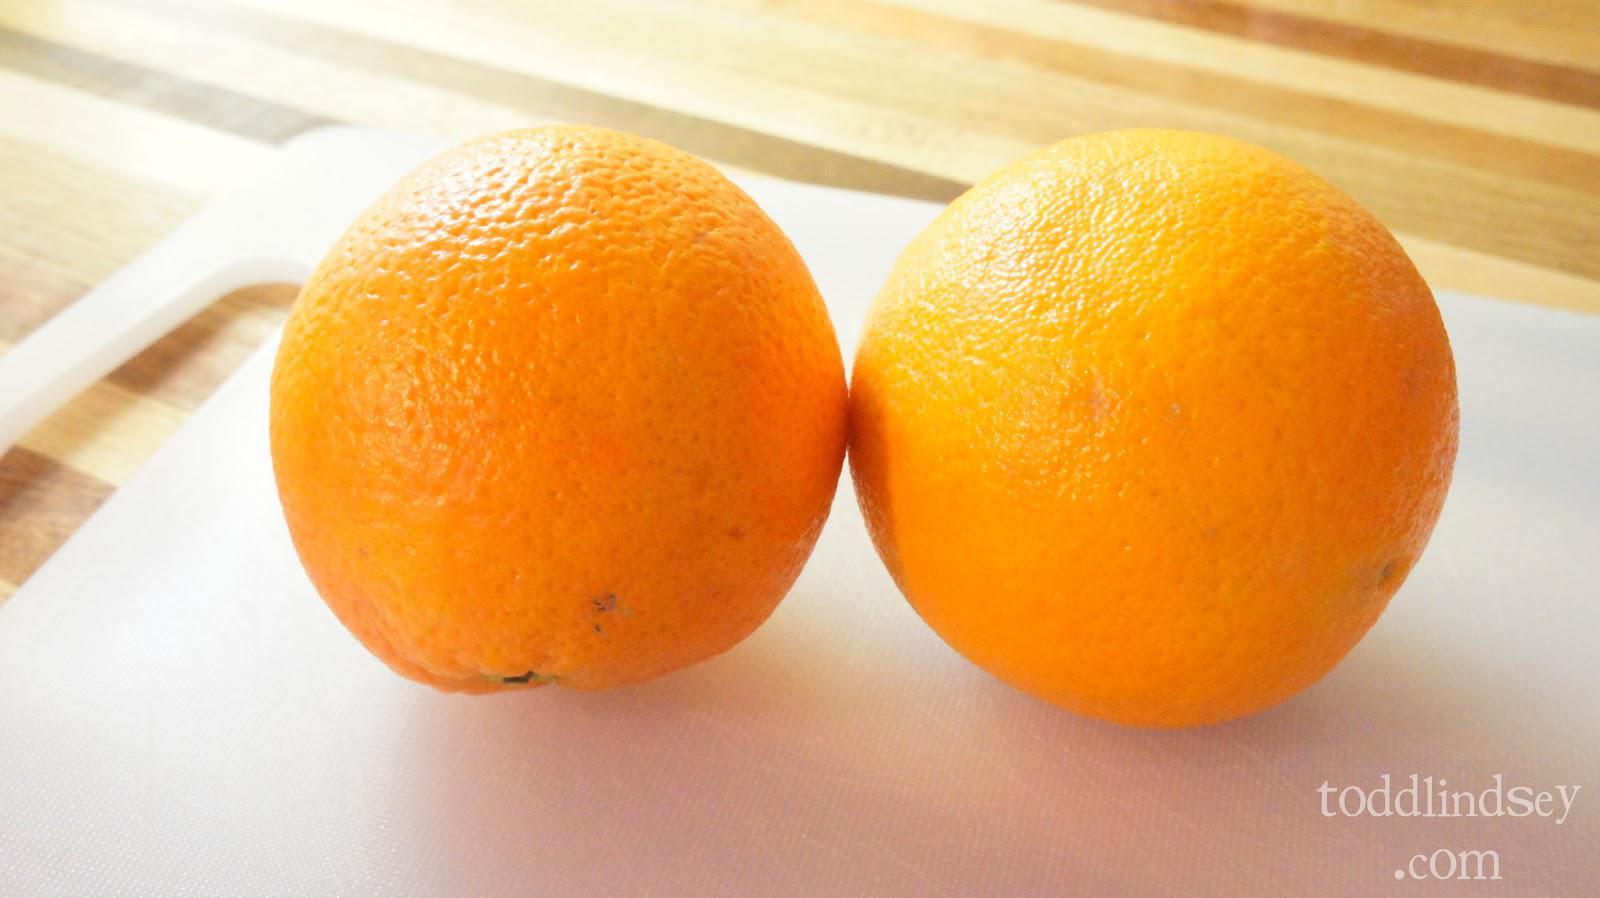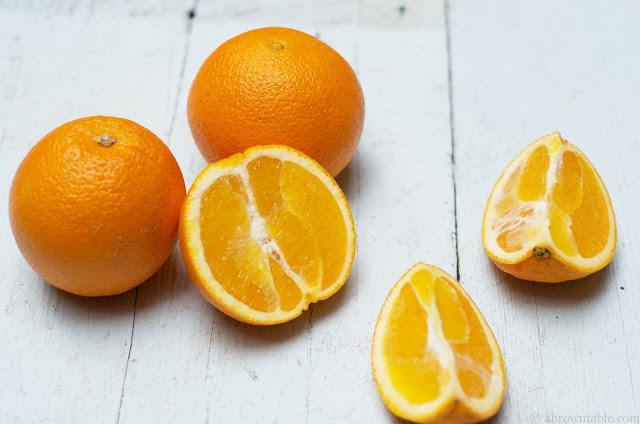The first image is the image on the left, the second image is the image on the right. Given the left and right images, does the statement "There are four unpeeled oranges in the pair of images." hold true? Answer yes or no. Yes. The first image is the image on the left, the second image is the image on the right. Assess this claim about the two images: "One of the images has two whole oranges with no partially cut oranges.". Correct or not? Answer yes or no. Yes. 